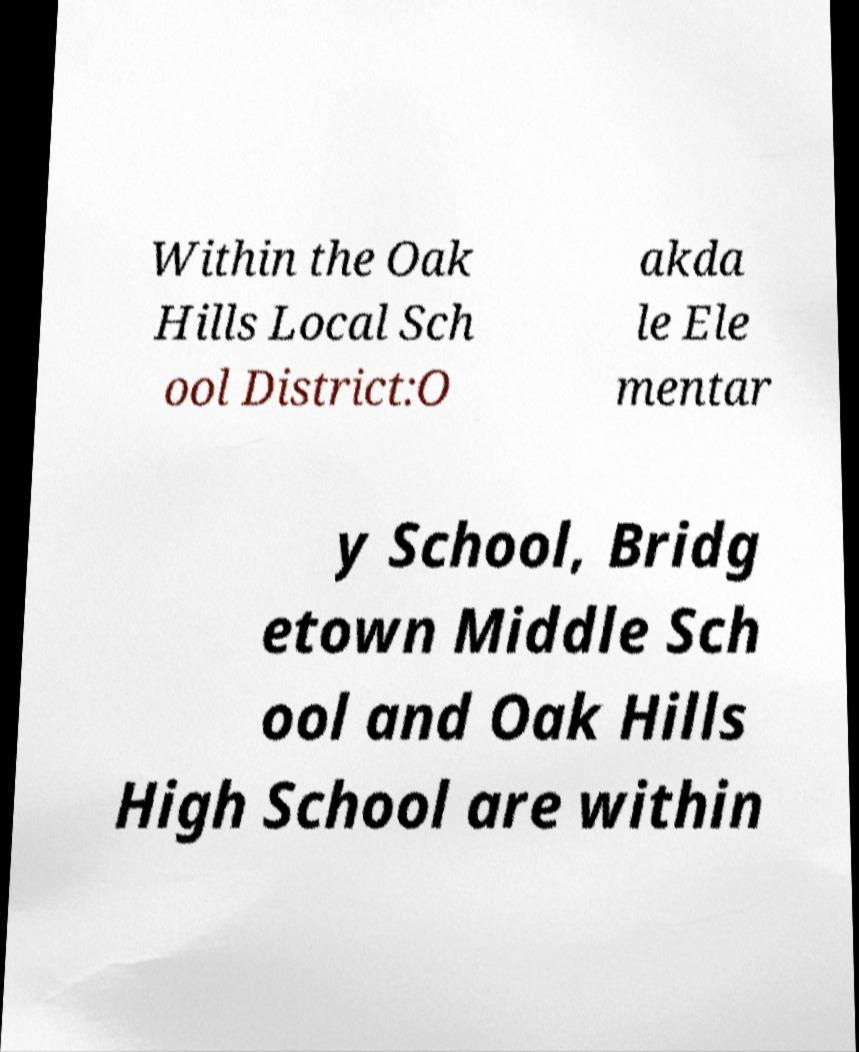Can you read and provide the text displayed in the image?This photo seems to have some interesting text. Can you extract and type it out for me? Within the Oak Hills Local Sch ool District:O akda le Ele mentar y School, Bridg etown Middle Sch ool and Oak Hills High School are within 